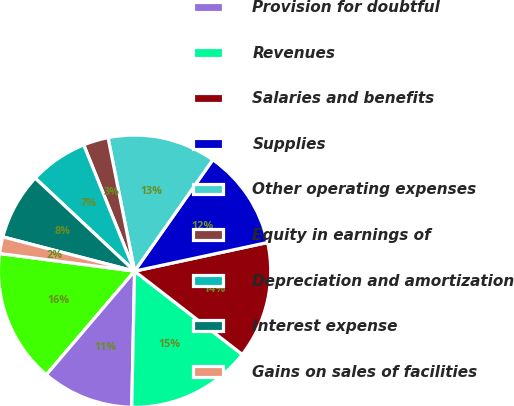<chart> <loc_0><loc_0><loc_500><loc_500><pie_chart><fcel>Revenues before the provision<fcel>Provision for doubtful<fcel>Revenues<fcel>Salaries and benefits<fcel>Supplies<fcel>Other operating expenses<fcel>Equity in earnings of<fcel>Depreciation and amortization<fcel>Interest expense<fcel>Gains on sales of facilities<nl><fcel>15.84%<fcel>10.89%<fcel>14.85%<fcel>13.86%<fcel>11.88%<fcel>12.87%<fcel>2.97%<fcel>6.93%<fcel>7.92%<fcel>1.98%<nl></chart> 